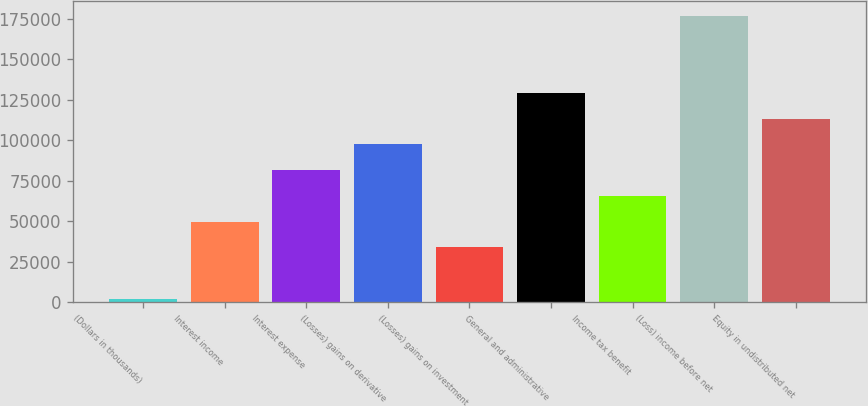Convert chart. <chart><loc_0><loc_0><loc_500><loc_500><bar_chart><fcel>(Dollars in thousands)<fcel>Interest income<fcel>Interest expense<fcel>(Losses) gains on derivative<fcel>(Losses) gains on investment<fcel>General and administrative<fcel>Income tax benefit<fcel>(Loss) income before net<fcel>Equity in undistributed net<nl><fcel>2007<fcel>49752.3<fcel>81582.5<fcel>97497.6<fcel>33837.2<fcel>129328<fcel>65667.4<fcel>177073<fcel>113413<nl></chart> 